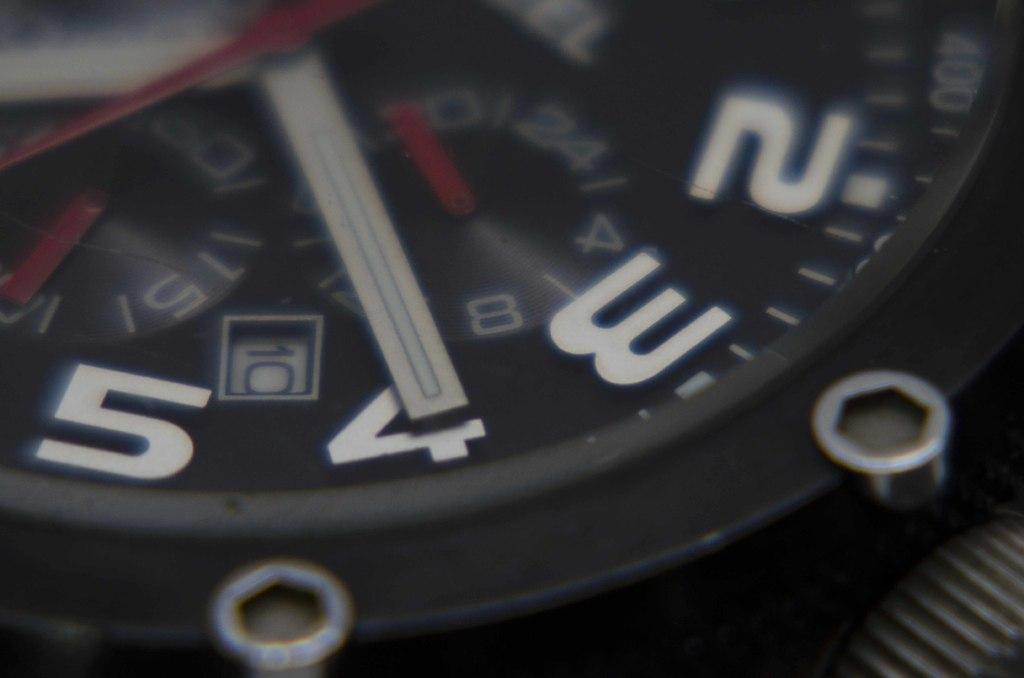<image>
Relay a brief, clear account of the picture shown. Wristwatch with the hand on the number 4. 